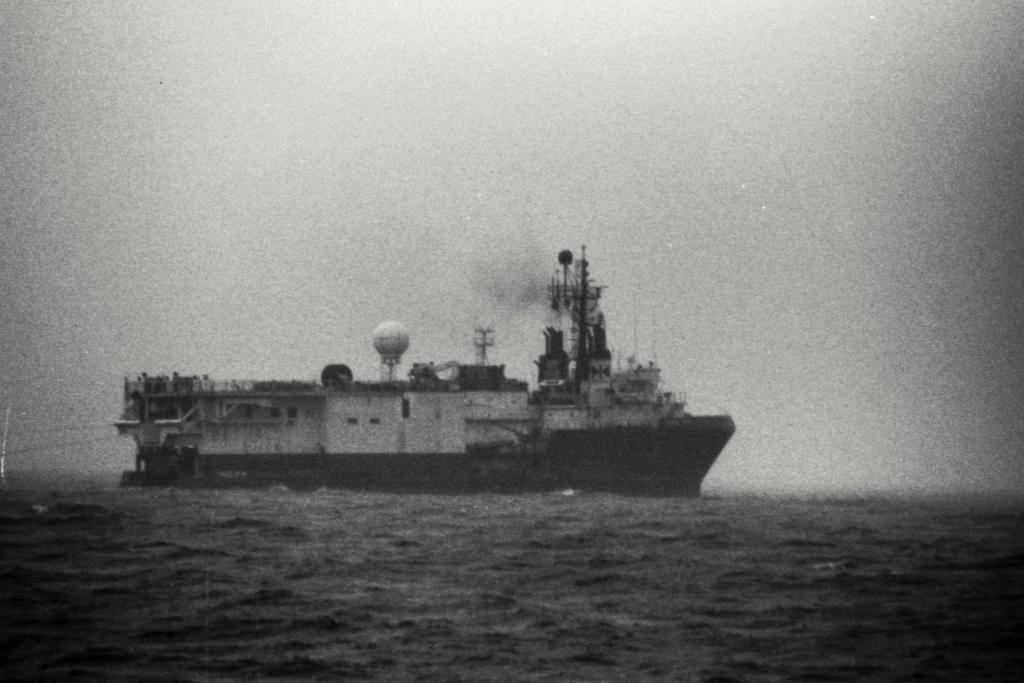Could you give a brief overview of what you see in this image? As we can see in the image there is water, boat and sky. The image is little dark. 